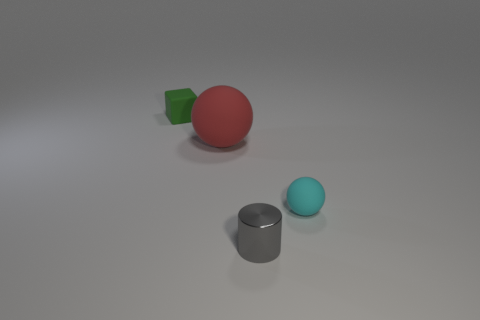What material is the thing that is in front of the ball that is in front of the large rubber object?
Make the answer very short. Metal. Is there anything else that has the same size as the cyan sphere?
Keep it short and to the point. Yes. Is the matte block the same size as the cylinder?
Make the answer very short. Yes. How many objects are objects that are to the right of the green rubber thing or rubber balls that are on the left side of the gray metallic cylinder?
Your response must be concise. 3. Is the number of tiny rubber blocks in front of the cube greater than the number of small cyan spheres?
Make the answer very short. No. What number of other things are there of the same shape as the big red thing?
Provide a short and direct response. 1. What material is the small object that is in front of the large red object and left of the tiny cyan rubber ball?
Offer a very short reply. Metal. How many things are small metallic things or large things?
Ensure brevity in your answer.  2. Are there more brown things than large red rubber things?
Provide a short and direct response. No. How big is the matte ball that is to the left of the sphere that is right of the tiny cylinder?
Offer a very short reply. Large. 